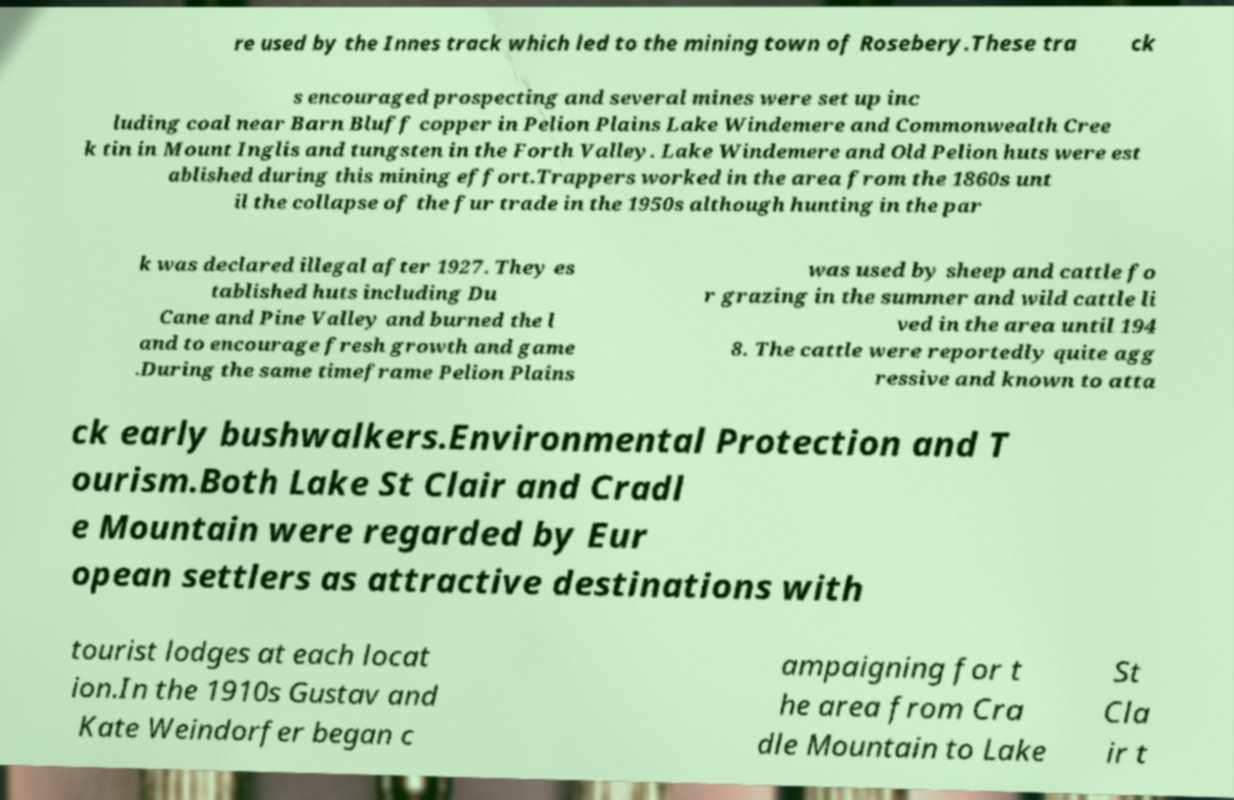Could you extract and type out the text from this image? re used by the Innes track which led to the mining town of Rosebery.These tra ck s encouraged prospecting and several mines were set up inc luding coal near Barn Bluff copper in Pelion Plains Lake Windemere and Commonwealth Cree k tin in Mount Inglis and tungsten in the Forth Valley. Lake Windemere and Old Pelion huts were est ablished during this mining effort.Trappers worked in the area from the 1860s unt il the collapse of the fur trade in the 1950s although hunting in the par k was declared illegal after 1927. They es tablished huts including Du Cane and Pine Valley and burned the l and to encourage fresh growth and game .During the same timeframe Pelion Plains was used by sheep and cattle fo r grazing in the summer and wild cattle li ved in the area until 194 8. The cattle were reportedly quite agg ressive and known to atta ck early bushwalkers.Environmental Protection and T ourism.Both Lake St Clair and Cradl e Mountain were regarded by Eur opean settlers as attractive destinations with tourist lodges at each locat ion.In the 1910s Gustav and Kate Weindorfer began c ampaigning for t he area from Cra dle Mountain to Lake St Cla ir t 